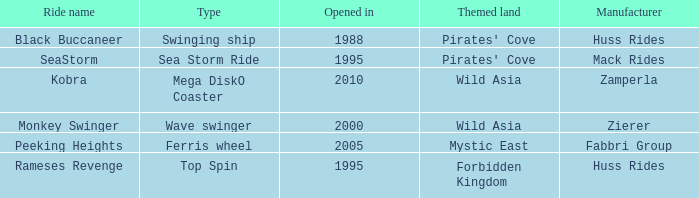What kind of attraction is rameses revenge? Top Spin. 